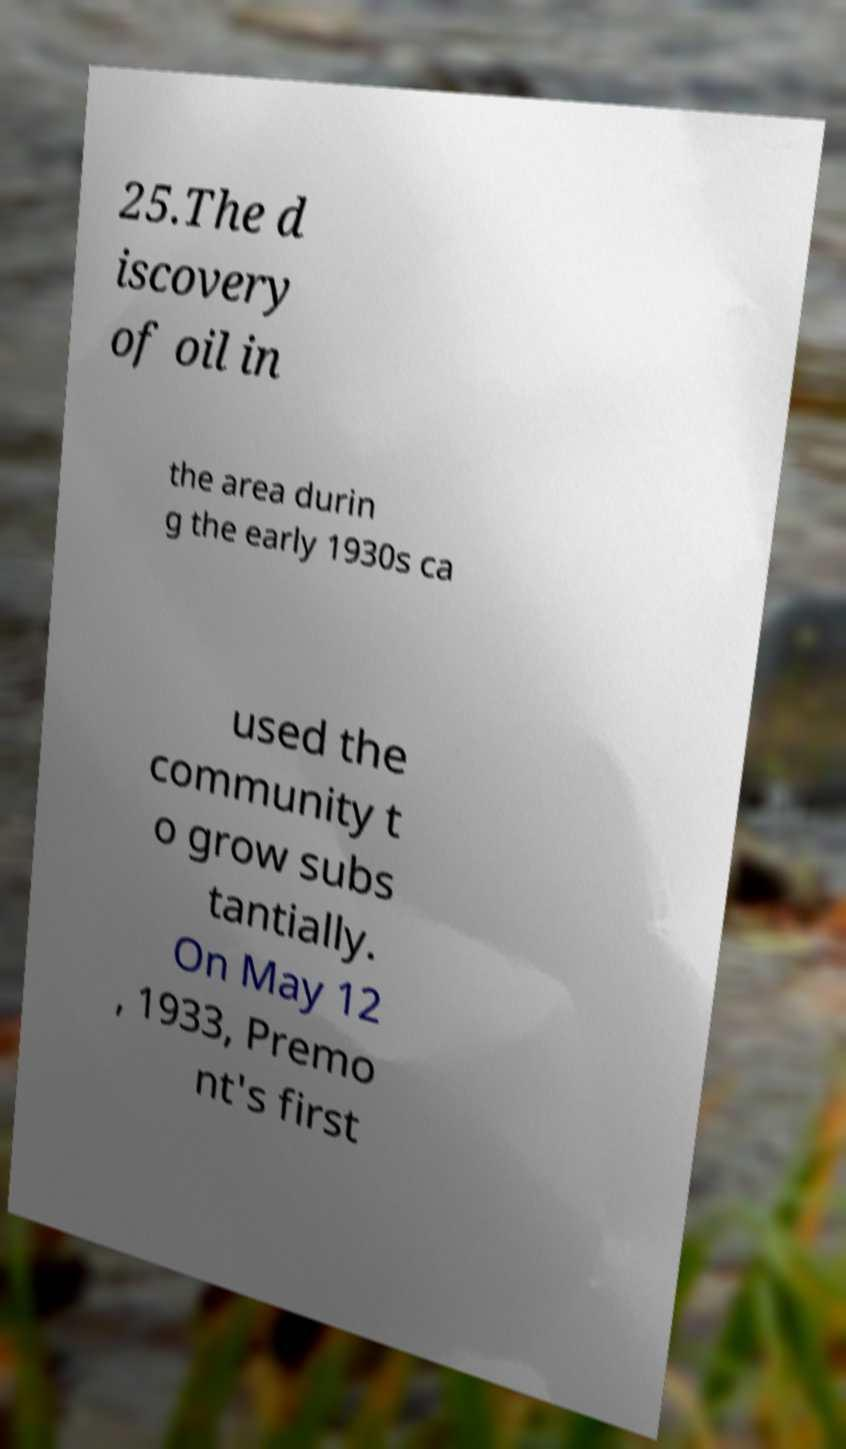I need the written content from this picture converted into text. Can you do that? 25.The d iscovery of oil in the area durin g the early 1930s ca used the community t o grow subs tantially. On May 12 , 1933, Premo nt's first 